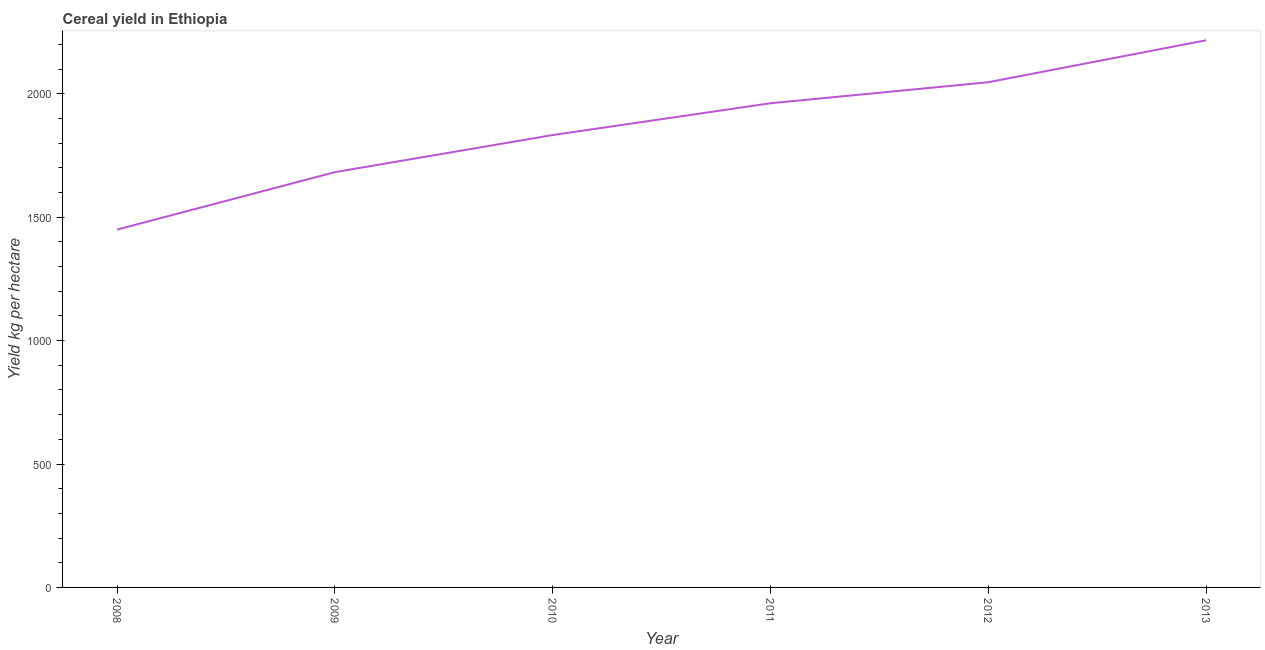What is the cereal yield in 2010?
Provide a succinct answer. 1832.8. Across all years, what is the maximum cereal yield?
Offer a terse response. 2216.73. Across all years, what is the minimum cereal yield?
Ensure brevity in your answer.  1449.73. In which year was the cereal yield maximum?
Keep it short and to the point. 2013. In which year was the cereal yield minimum?
Your answer should be compact. 2008. What is the sum of the cereal yield?
Ensure brevity in your answer.  1.12e+04. What is the difference between the cereal yield in 2010 and 2013?
Keep it short and to the point. -383.93. What is the average cereal yield per year?
Ensure brevity in your answer.  1865.02. What is the median cereal yield?
Your answer should be very brief. 1897.21. Do a majority of the years between 2009 and 2010 (inclusive) have cereal yield greater than 700 kg per hectare?
Your answer should be compact. Yes. What is the ratio of the cereal yield in 2010 to that in 2011?
Offer a very short reply. 0.93. Is the cereal yield in 2008 less than that in 2010?
Make the answer very short. Yes. Is the difference between the cereal yield in 2009 and 2010 greater than the difference between any two years?
Your answer should be compact. No. What is the difference between the highest and the second highest cereal yield?
Your response must be concise. 169.96. What is the difference between the highest and the lowest cereal yield?
Ensure brevity in your answer.  767. Are the values on the major ticks of Y-axis written in scientific E-notation?
Provide a succinct answer. No. Does the graph contain any zero values?
Your answer should be very brief. No. Does the graph contain grids?
Give a very brief answer. No. What is the title of the graph?
Offer a very short reply. Cereal yield in Ethiopia. What is the label or title of the Y-axis?
Your answer should be compact. Yield kg per hectare. What is the Yield kg per hectare of 2008?
Make the answer very short. 1449.73. What is the Yield kg per hectare in 2009?
Make the answer very short. 1682.46. What is the Yield kg per hectare in 2010?
Keep it short and to the point. 1832.8. What is the Yield kg per hectare in 2011?
Your answer should be very brief. 1961.62. What is the Yield kg per hectare of 2012?
Offer a terse response. 2046.77. What is the Yield kg per hectare of 2013?
Provide a short and direct response. 2216.73. What is the difference between the Yield kg per hectare in 2008 and 2009?
Make the answer very short. -232.73. What is the difference between the Yield kg per hectare in 2008 and 2010?
Provide a short and direct response. -383.07. What is the difference between the Yield kg per hectare in 2008 and 2011?
Your response must be concise. -511.88. What is the difference between the Yield kg per hectare in 2008 and 2012?
Provide a short and direct response. -597.04. What is the difference between the Yield kg per hectare in 2008 and 2013?
Give a very brief answer. -767. What is the difference between the Yield kg per hectare in 2009 and 2010?
Your response must be concise. -150.34. What is the difference between the Yield kg per hectare in 2009 and 2011?
Ensure brevity in your answer.  -279.15. What is the difference between the Yield kg per hectare in 2009 and 2012?
Provide a short and direct response. -364.31. What is the difference between the Yield kg per hectare in 2009 and 2013?
Provide a short and direct response. -534.27. What is the difference between the Yield kg per hectare in 2010 and 2011?
Make the answer very short. -128.81. What is the difference between the Yield kg per hectare in 2010 and 2012?
Offer a terse response. -213.97. What is the difference between the Yield kg per hectare in 2010 and 2013?
Provide a succinct answer. -383.93. What is the difference between the Yield kg per hectare in 2011 and 2012?
Make the answer very short. -85.16. What is the difference between the Yield kg per hectare in 2011 and 2013?
Keep it short and to the point. -255.11. What is the difference between the Yield kg per hectare in 2012 and 2013?
Make the answer very short. -169.96. What is the ratio of the Yield kg per hectare in 2008 to that in 2009?
Keep it short and to the point. 0.86. What is the ratio of the Yield kg per hectare in 2008 to that in 2010?
Your response must be concise. 0.79. What is the ratio of the Yield kg per hectare in 2008 to that in 2011?
Your response must be concise. 0.74. What is the ratio of the Yield kg per hectare in 2008 to that in 2012?
Provide a short and direct response. 0.71. What is the ratio of the Yield kg per hectare in 2008 to that in 2013?
Ensure brevity in your answer.  0.65. What is the ratio of the Yield kg per hectare in 2009 to that in 2010?
Provide a short and direct response. 0.92. What is the ratio of the Yield kg per hectare in 2009 to that in 2011?
Ensure brevity in your answer.  0.86. What is the ratio of the Yield kg per hectare in 2009 to that in 2012?
Offer a very short reply. 0.82. What is the ratio of the Yield kg per hectare in 2009 to that in 2013?
Provide a short and direct response. 0.76. What is the ratio of the Yield kg per hectare in 2010 to that in 2011?
Make the answer very short. 0.93. What is the ratio of the Yield kg per hectare in 2010 to that in 2012?
Keep it short and to the point. 0.9. What is the ratio of the Yield kg per hectare in 2010 to that in 2013?
Keep it short and to the point. 0.83. What is the ratio of the Yield kg per hectare in 2011 to that in 2012?
Provide a succinct answer. 0.96. What is the ratio of the Yield kg per hectare in 2011 to that in 2013?
Provide a succinct answer. 0.89. What is the ratio of the Yield kg per hectare in 2012 to that in 2013?
Your answer should be compact. 0.92. 